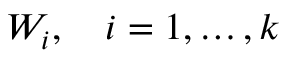Convert formula to latex. <formula><loc_0><loc_0><loc_500><loc_500>W _ { i } , \quad i = 1 , \dots , k</formula> 